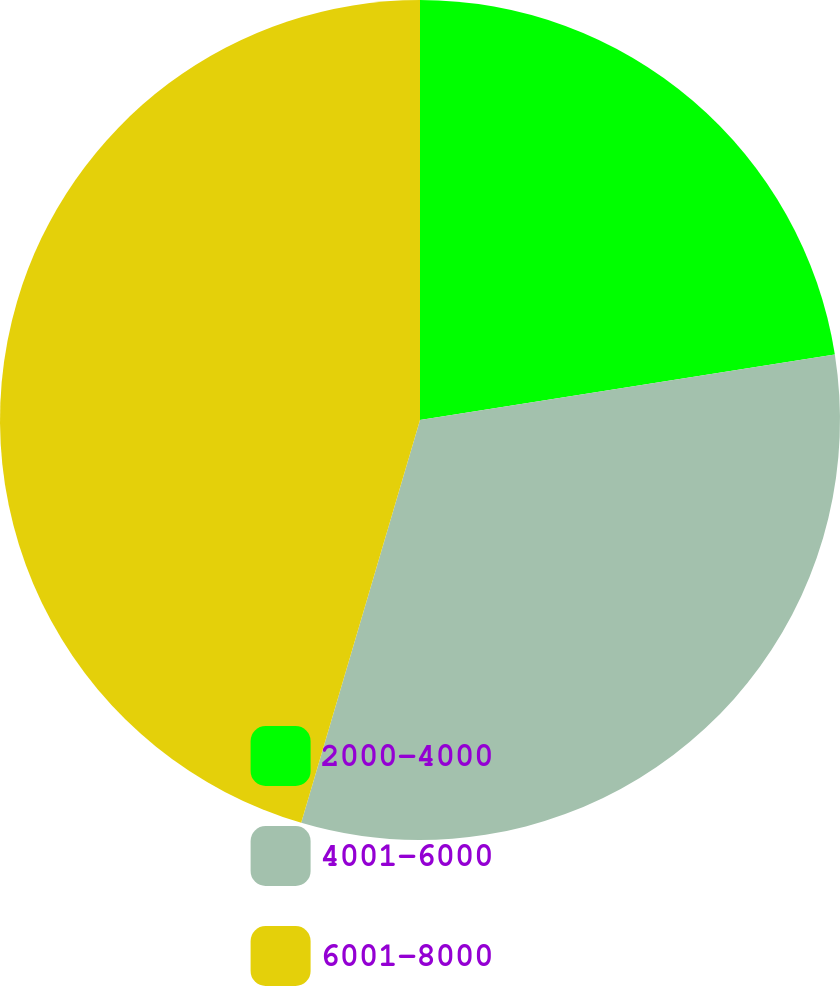Convert chart. <chart><loc_0><loc_0><loc_500><loc_500><pie_chart><fcel>2000-4000<fcel>4001-6000<fcel>6001-8000<nl><fcel>22.51%<fcel>32.06%<fcel>45.44%<nl></chart> 